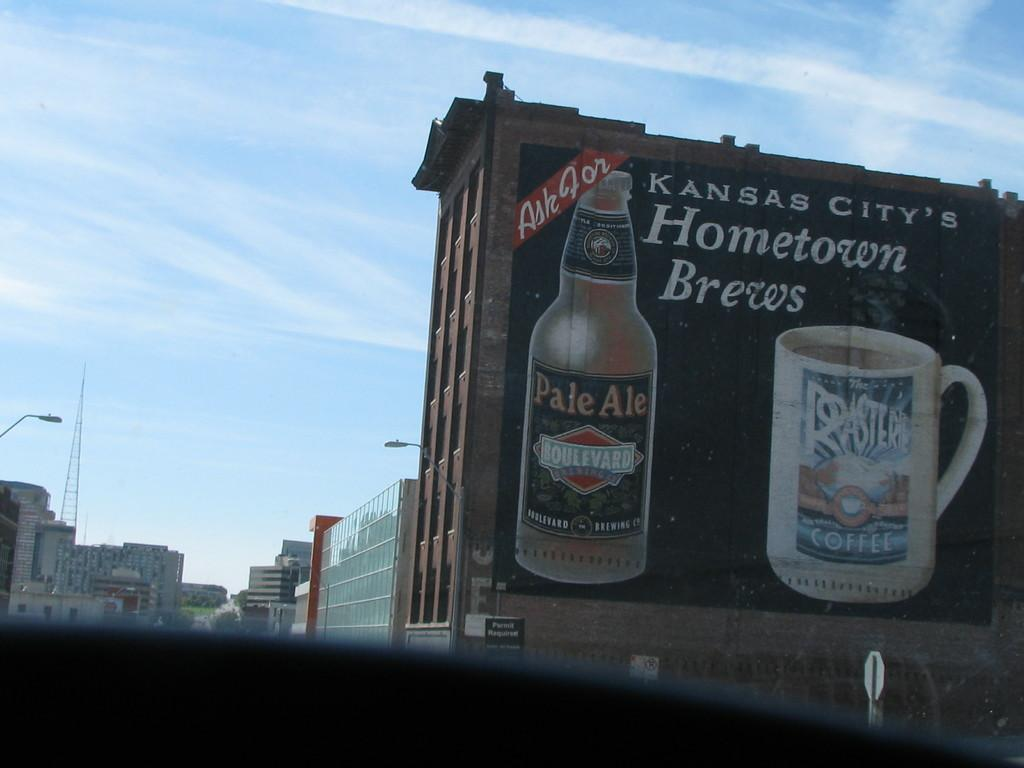<image>
Relay a brief, clear account of the picture shown. the side of a building with a sign that says 'kansas city's hometown brews' on it 